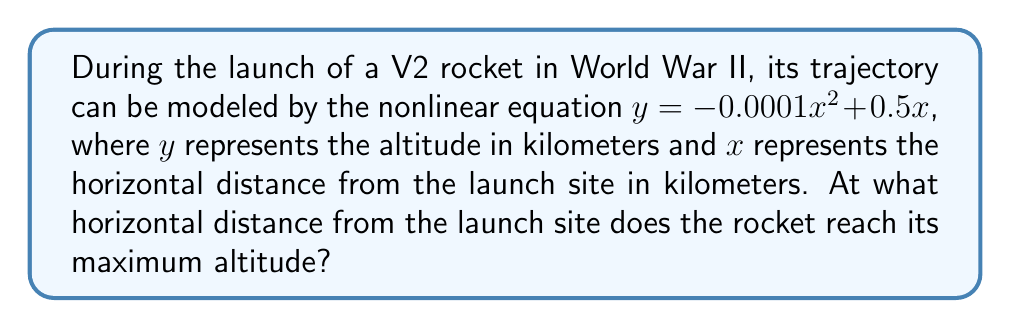Give your solution to this math problem. To find the maximum altitude of the rocket's trajectory, we need to follow these steps:

1) The trajectory is given by the quadratic equation:
   $y = -0.0001x^2 + 0.5x$

2) To find the maximum point, we need to find where the derivative of this function equals zero:
   $\frac{dy}{dx} = -0.0002x + 0.5$

3) Set this equal to zero and solve for x:
   $-0.0002x + 0.5 = 0$
   $-0.0002x = -0.5$
   $x = \frac{-0.5}{-0.0002} = 2500$

4) To confirm this is a maximum (not a minimum), we can check the second derivative:
   $\frac{d^2y}{dx^2} = -0.0002$
   Since this is negative, we confirm it's a maximum.

5) Therefore, the rocket reaches its maximum altitude when $x = 2500$ km from the launch site.

This result aligns with the parabolic nature of the trajectory, reaching its peak halfway through its flight path before descending.
Answer: 2500 km 